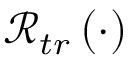Convert formula to latex. <formula><loc_0><loc_0><loc_500><loc_500>\mathcal { R } _ { t r } \left ( \cdot \right )</formula> 